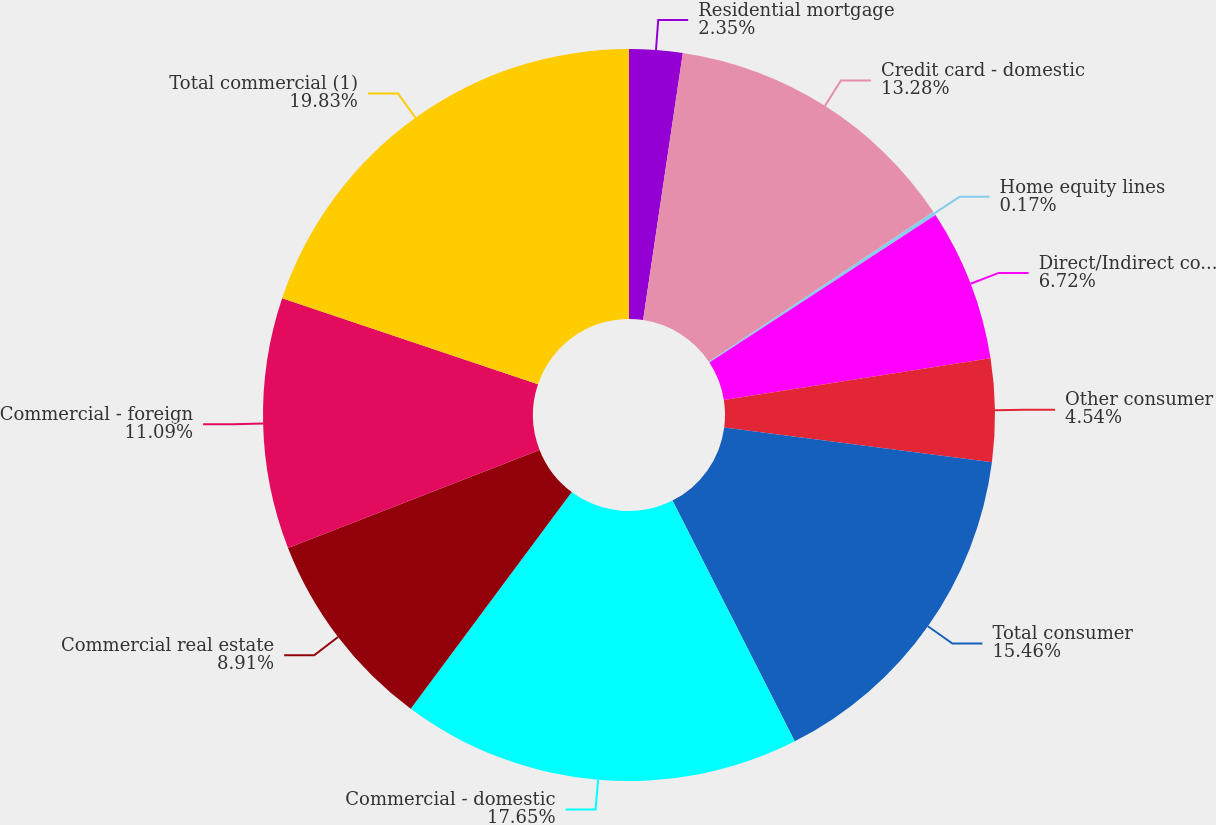Convert chart to OTSL. <chart><loc_0><loc_0><loc_500><loc_500><pie_chart><fcel>Residential mortgage<fcel>Credit card - domestic<fcel>Home equity lines<fcel>Direct/Indirect consumer<fcel>Other consumer<fcel>Total consumer<fcel>Commercial - domestic<fcel>Commercial real estate<fcel>Commercial - foreign<fcel>Total commercial (1)<nl><fcel>2.35%<fcel>13.28%<fcel>0.17%<fcel>6.72%<fcel>4.54%<fcel>15.46%<fcel>17.65%<fcel>8.91%<fcel>11.09%<fcel>19.83%<nl></chart> 